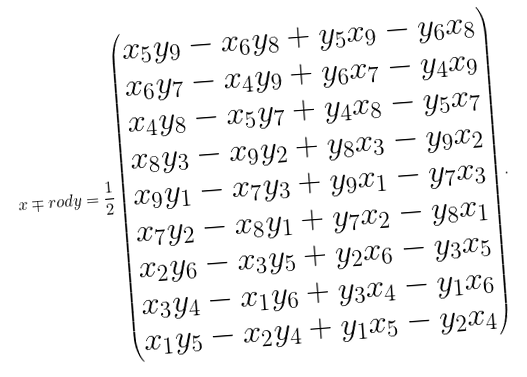<formula> <loc_0><loc_0><loc_500><loc_500>x \mp r o d y = \frac { 1 } { 2 } \begin{pmatrix} x _ { 5 } y _ { 9 } - x _ { 6 } y _ { 8 } + y _ { 5 } x _ { 9 } - y _ { 6 } x _ { 8 } \\ x _ { 6 } y _ { 7 } - x _ { 4 } y _ { 9 } + y _ { 6 } x _ { 7 } - y _ { 4 } x _ { 9 } \\ x _ { 4 } y _ { 8 } - x _ { 5 } y _ { 7 } + y _ { 4 } x _ { 8 } - y _ { 5 } x _ { 7 } \\ x _ { 8 } y _ { 3 } - x _ { 9 } y _ { 2 } + y _ { 8 } x _ { 3 } - y _ { 9 } x _ { 2 } \\ x _ { 9 } y _ { 1 } - x _ { 7 } y _ { 3 } + y _ { 9 } x _ { 1 } - y _ { 7 } x _ { 3 } \\ x _ { 7 } y _ { 2 } - x _ { 8 } y _ { 1 } + y _ { 7 } x _ { 2 } - y _ { 8 } x _ { 1 } \\ x _ { 2 } y _ { 6 } - x _ { 3 } y _ { 5 } + y _ { 2 } x _ { 6 } - y _ { 3 } x _ { 5 } \\ x _ { 3 } y _ { 4 } - x _ { 1 } y _ { 6 } + y _ { 3 } x _ { 4 } - y _ { 1 } x _ { 6 } \\ x _ { 1 } y _ { 5 } - x _ { 2 } y _ { 4 } + y _ { 1 } x _ { 5 } - y _ { 2 } x _ { 4 } \end{pmatrix} .</formula> 